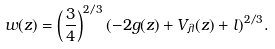Convert formula to latex. <formula><loc_0><loc_0><loc_500><loc_500>w ( z ) = \left ( \frac { 3 } { 4 } \right ) ^ { 2 / 3 } ( - 2 g ( z ) + V _ { \lambda } ( z ) + l ) ^ { 2 / 3 } .</formula> 